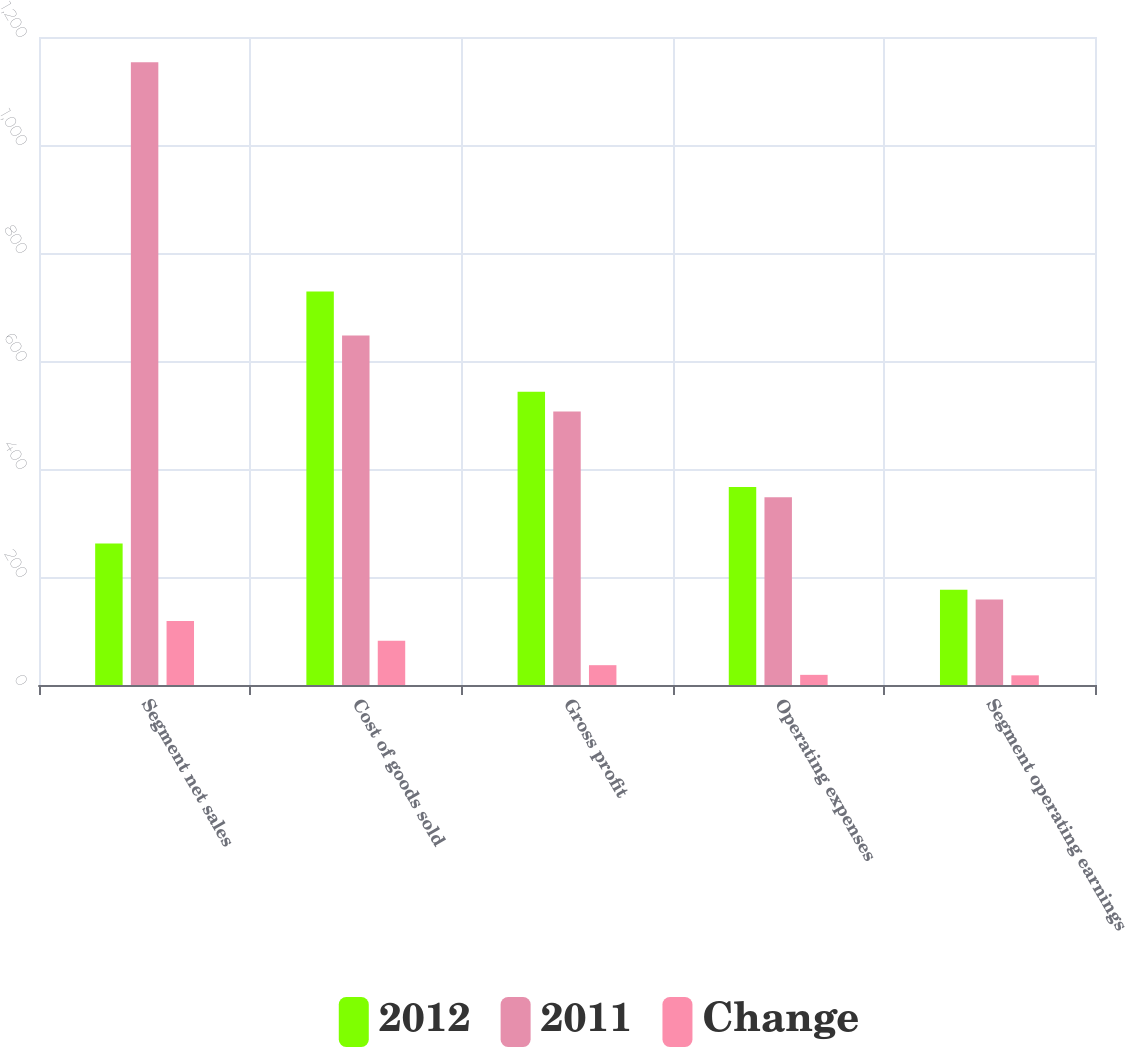Convert chart to OTSL. <chart><loc_0><loc_0><loc_500><loc_500><stacked_bar_chart><ecel><fcel>Segment net sales<fcel>Cost of goods sold<fcel>Gross profit<fcel>Operating expenses<fcel>Segment operating earnings<nl><fcel>2012<fcel>262.15<fcel>728.9<fcel>543.1<fcel>366.7<fcel>176.4<nl><fcel>2011<fcel>1153.4<fcel>647<fcel>506.4<fcel>347.9<fcel>158.5<nl><fcel>Change<fcel>118.6<fcel>81.9<fcel>36.7<fcel>18.8<fcel>17.9<nl></chart> 